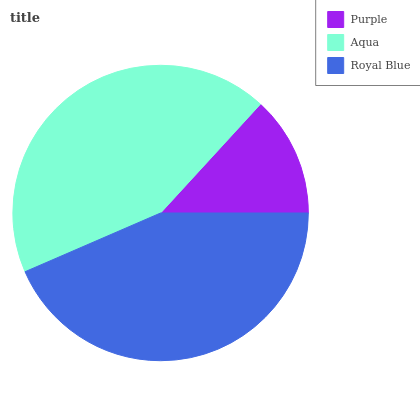Is Purple the minimum?
Answer yes or no. Yes. Is Royal Blue the maximum?
Answer yes or no. Yes. Is Aqua the minimum?
Answer yes or no. No. Is Aqua the maximum?
Answer yes or no. No. Is Aqua greater than Purple?
Answer yes or no. Yes. Is Purple less than Aqua?
Answer yes or no. Yes. Is Purple greater than Aqua?
Answer yes or no. No. Is Aqua less than Purple?
Answer yes or no. No. Is Aqua the high median?
Answer yes or no. Yes. Is Aqua the low median?
Answer yes or no. Yes. Is Purple the high median?
Answer yes or no. No. Is Purple the low median?
Answer yes or no. No. 